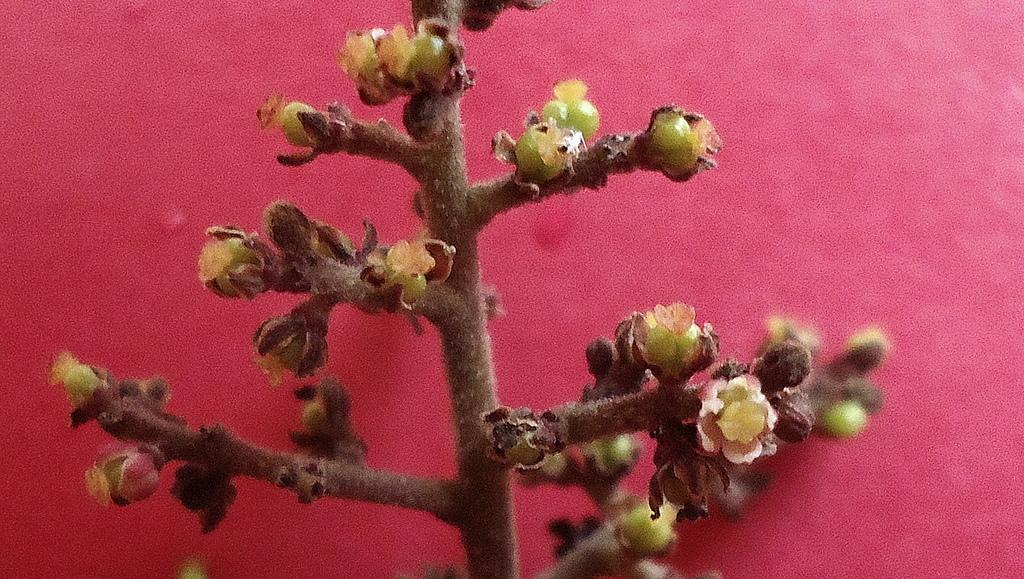What is present in the image? There is a plant in the image. What color is the background of the image? The background of the image is red in color. How does the plant pull the basket in the image? There is no basket present in the image, and plants do not have the ability to pull objects. 